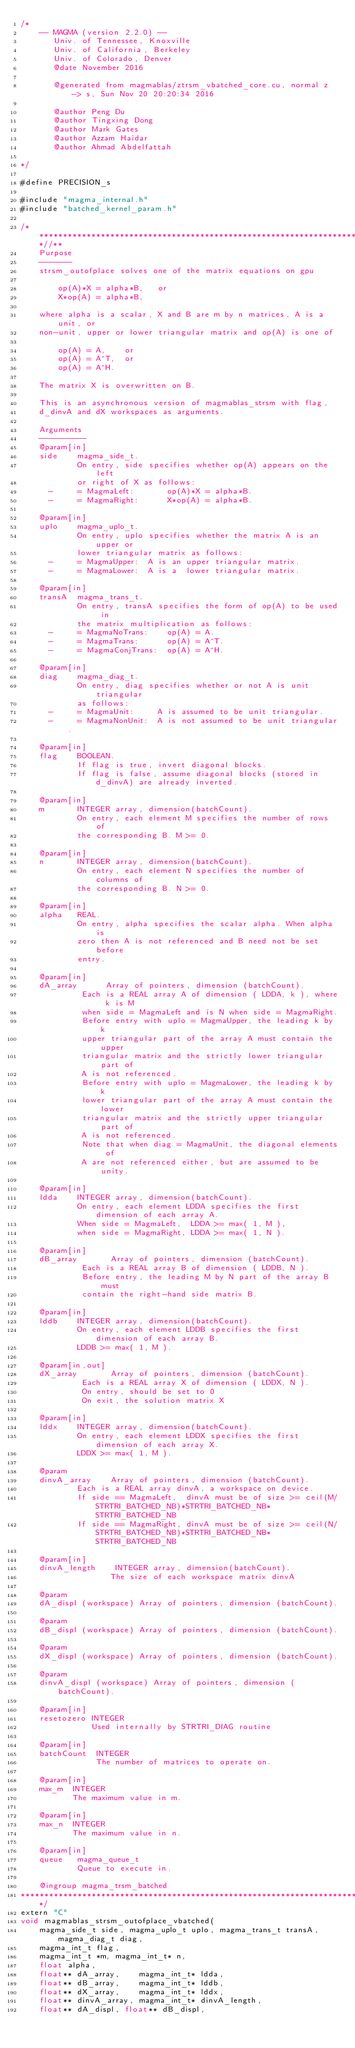<code> <loc_0><loc_0><loc_500><loc_500><_Cuda_>/*
    -- MAGMA (version 2.2.0) --
       Univ. of Tennessee, Knoxville
       Univ. of California, Berkeley
       Univ. of Colorado, Denver
       @date November 2016

       @generated from magmablas/ztrsm_vbatched_core.cu, normal z -> s, Sun Nov 20 20:20:34 2016

       @author Peng Du
       @author Tingxing Dong
       @author Mark Gates
       @author Azzam Haidar
       @author Ahmad Abdelfattah
       
*/

#define PRECISION_s

#include "magma_internal.h"
#include "batched_kernel_param.h"

/***************************************************************************//**
    Purpose
    -------
    strsm_outofplace solves one of the matrix equations on gpu

        op(A)*X = alpha*B,   or
        X*op(A) = alpha*B,

    where alpha is a scalar, X and B are m by n matrices, A is a unit, or
    non-unit, upper or lower triangular matrix and op(A) is one of

        op(A) = A,    or
        op(A) = A^T,  or
        op(A) = A^H.

    The matrix X is overwritten on B.

    This is an asynchronous version of magmablas_strsm with flag,
    d_dinvA and dX workspaces as arguments.

    Arguments
    ----------
    @param[in]
    side    magma_side_t.
            On entry, side specifies whether op(A) appears on the left
            or right of X as follows:
      -     = MagmaLeft:       op(A)*X = alpha*B.
      -     = MagmaRight:      X*op(A) = alpha*B.

    @param[in]
    uplo    magma_uplo_t.
            On entry, uplo specifies whether the matrix A is an upper or
            lower triangular matrix as follows:
      -     = MagmaUpper:  A is an upper triangular matrix.
      -     = MagmaLower:  A is a  lower triangular matrix.

    @param[in]
    transA  magma_trans_t.
            On entry, transA specifies the form of op(A) to be used in
            the matrix multiplication as follows:
      -     = MagmaNoTrans:    op(A) = A.
      -     = MagmaTrans:      op(A) = A^T.
      -     = MagmaConjTrans:  op(A) = A^H.

    @param[in]
    diag    magma_diag_t.
            On entry, diag specifies whether or not A is unit triangular
            as follows:
      -     = MagmaUnit:     A is assumed to be unit triangular.
      -     = MagmaNonUnit:  A is not assumed to be unit triangular.

    @param[in]
    flag    BOOLEAN.
            If flag is true, invert diagonal blocks.
            If flag is false, assume diagonal blocks (stored in d_dinvA) are already inverted.

    @param[in]
    m       INTEGER array, dimension(batchCount).
            On entry, each element M specifies the number of rows of 
            the corresponding B. M >= 0.

    @param[in]
    n       INTEGER array, dimension(batchCount).
            On entry, each element N specifies the number of columns of 
            the corresponding B. N >= 0.

    @param[in]
    alpha   REAL.
            On entry, alpha specifies the scalar alpha. When alpha is
            zero then A is not referenced and B need not be set before
            entry.

    @param[in]
    dA_array      Array of pointers, dimension (batchCount).
             Each is a REAL array A of dimension ( LDDA, k ), where k is M
             when side = MagmaLeft and is N when side = MagmaRight.
             Before entry with uplo = MagmaUpper, the leading k by k
             upper triangular part of the array A must contain the upper
             triangular matrix and the strictly lower triangular part of
             A is not referenced.
             Before entry with uplo = MagmaLower, the leading k by k
             lower triangular part of the array A must contain the lower
             triangular matrix and the strictly upper triangular part of
             A is not referenced.
             Note that when diag = MagmaUnit, the diagonal elements of
             A are not referenced either, but are assumed to be unity.

    @param[in]
    ldda    INTEGER array, dimension(batchCount).
            On entry, each element LDDA specifies the first dimension of each array A.
            When side = MagmaLeft,  LDDA >= max( 1, M ),
            when side = MagmaRight, LDDA >= max( 1, N ).

    @param[in]
    dB_array       Array of pointers, dimension (batchCount).
             Each is a REAL array B of dimension ( LDDB, N ).
             Before entry, the leading M by N part of the array B must
             contain the right-hand side matrix B.

    @param[in]
    lddb    INTEGER array, dimension(batchCount).
            On entry, each element LDDB specifies the first dimension of each array B.
            LDDB >= max( 1, M ).

    @param[in,out]
    dX_array       Array of pointers, dimension (batchCount).
             Each is a REAL array X of dimension ( LDDX, N ).
             On entry, should be set to 0
             On exit, the solution matrix X

    @param[in]
    lddx    INTEGER array, dimension(batchCount).
            On entry, each element LDDX specifies the first dimension of each array X.
            LDDX >= max( 1, M ).

    @param
    dinvA_array    Array of pointers, dimension (batchCount).
            Each is a REAL array dinvA, a workspace on device.
            If side == MagmaLeft,  dinvA must be of size >= ceil(M/STRTRI_BATCHED_NB)*STRTRI_BATCHED_NB*STRTRI_BATCHED_NB
            If side == MagmaRight, dinvA must be of size >= ceil(N/STRTRI_BATCHED_NB)*STRTRI_BATCHED_NB*STRTRI_BATCHED_NB

    @param[in]
    dinvA_length    INTEGER array, dimension(batchCount). 
                   The size of each workspace matrix dinvA
                   
    @param
    dA_displ (workspace) Array of pointers, dimension (batchCount).
    
    @param
    dB_displ (workspace) Array of pointers, dimension (batchCount).
    
    @param
    dX_displ (workspace) Array of pointers, dimension (batchCount).
    
    @param
    dinvA_displ (workspace) Array of pointers, dimension (batchCount).
    
    @param[in]
    resetozero INTEGER
               Used internally by STRTRI_DIAG routine
    
    @param[in]
    batchCount  INTEGER
                The number of matrices to operate on.

    @param[in]
    max_m  INTEGER
           The maximum value in m.
    
    @param[in]
    max_n  INTEGER
           The maximum value in n.
    
    @param[in]
    queue   magma_queue_t
            Queue to execute in.
    
    @ingroup magma_trsm_batched
*******************************************************************************/
extern "C" 
void magmablas_strsm_outofplace_vbatched(
    magma_side_t side, magma_uplo_t uplo, magma_trans_t transA, magma_diag_t diag,
    magma_int_t flag, 
    magma_int_t *m, magma_int_t* n,
    float alpha, 
    float** dA_array,    magma_int_t* ldda,
    float** dB_array,    magma_int_t* lddb,
    float** dX_array,    magma_int_t* lddx, 
    float** dinvA_array, magma_int_t* dinvA_length,
    float** dA_displ, float** dB_displ, </code> 